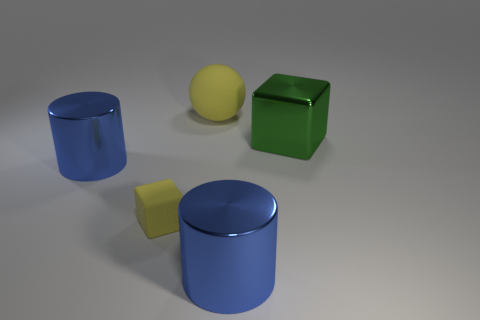How could the arrangement of these objects contribute to a study on light and shadows? The different shapes and positioning of these objects provide a perfect setup for observing how light produces varying shadows. The contrasts between sharp edges on the cube, the soft edges of the cylinder, and the seamless curve of the sphere allow for a comprehensive study of shadow gradients and contours under uniform lighting conditions. 